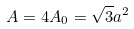<formula> <loc_0><loc_0><loc_500><loc_500>A = 4 A _ { 0 } = \sqrt { 3 } a ^ { 2 }</formula> 